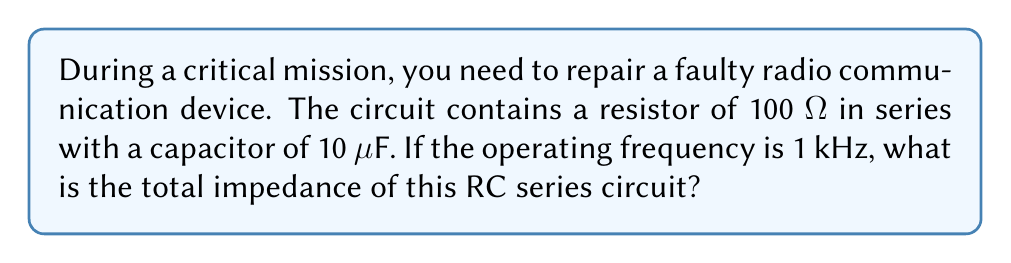Teach me how to tackle this problem. To solve this problem, we'll follow these steps:

1) The impedance of a resistor is simply its resistance: $Z_R = R = 100 \text{ Ω}$

2) For a capacitor, the impedance is given by:
   $Z_C = \frac{1}{j\omega C}$
   where $\omega = 2\pi f$ is the angular frequency, and $f$ is the frequency in Hz.

3) Calculate $\omega$:
   $\omega = 2\pi f = 2\pi(1000) = 6283.19 \text{ rad/s}$

4) Calculate the capacitive impedance:
   $Z_C = \frac{1}{j\omega C} = \frac{1}{j(6283.19)(10 \times 10^{-6})} = -j15915.5 \text{ Ω}$

5) The total impedance in a series circuit is the sum of individual impedances:
   $Z_{total} = Z_R + Z_C = 100 - j15915.5 \text{ Ω}$

6) To find the magnitude of the total impedance:
   $|Z_{total}| = \sqrt{R^2 + X_C^2} = \sqrt{100^2 + 15915.5^2} = 15915.8 \text{ Ω}$

7) The phase angle is:
   $\theta = \tan^{-1}(\frac{X_C}{R}) = \tan^{-1}(\frac{15915.5}{100}) = -89.64°$

Therefore, the total impedance in polar form is:
$Z_{total} = 15915.8 \angle -89.64° \text{ Ω}$
Answer: $15915.8 \angle -89.64° \text{ Ω}$ 